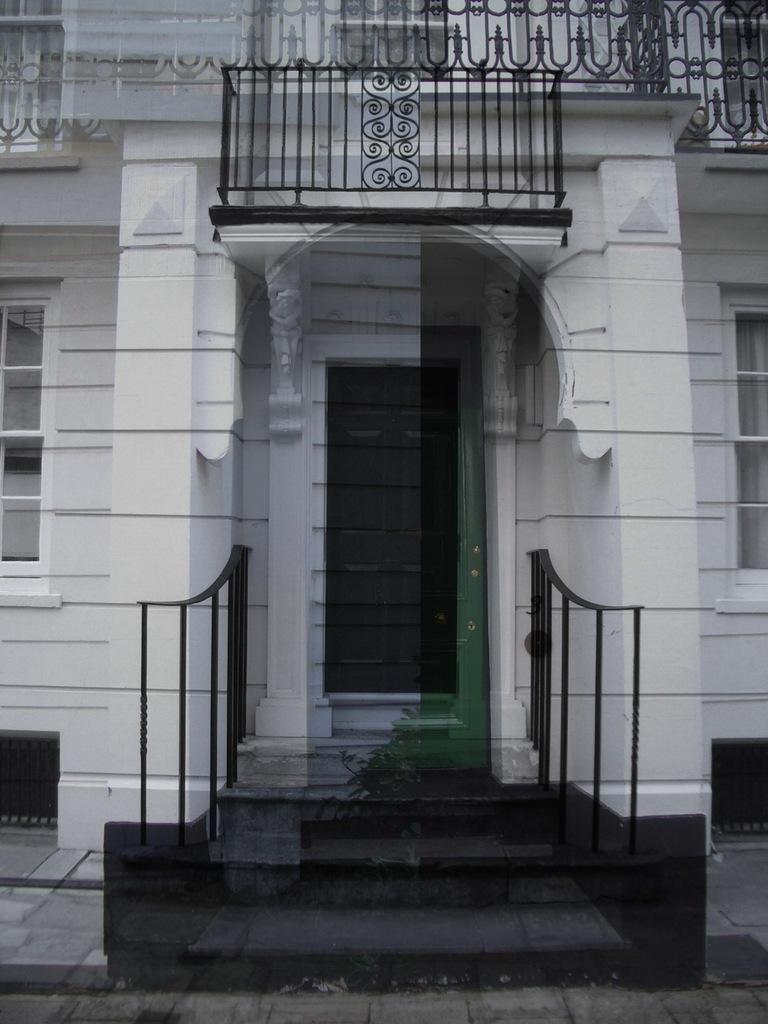What structure is the main subject of the image? There is a building in the image. What architectural feature is located in front of the building? There are stairs in front of the building. What safety feature is present alongside the stairs? There are handrails on both sides of the stairs. What can be seen at the top of the building? There are railings at the top of the building. Where is the copy of the book located in the image? There is no copy of a book present in the image. What type of drug can be seen being administered in the image? There is no drug or any medical procedure depicted in the image. 